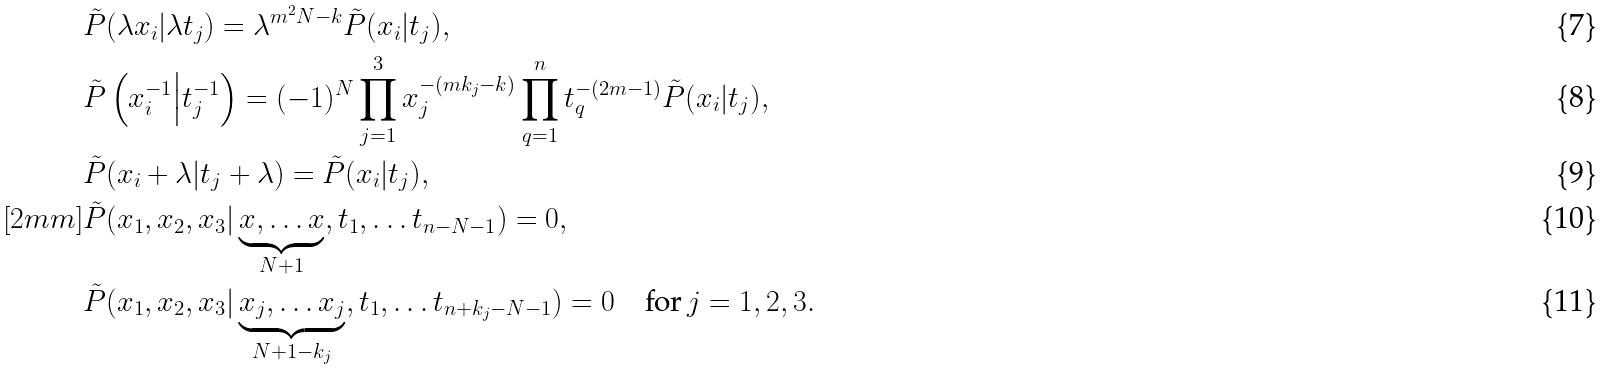Convert formula to latex. <formula><loc_0><loc_0><loc_500><loc_500>& \tilde { P } ( \lambda x _ { i } | \lambda t _ { j } ) = \lambda ^ { m ^ { 2 } N - k } \tilde { P } ( x _ { i } | t _ { j } ) , \\ & \tilde { P } \left ( x _ { i } ^ { - 1 } \Big | t _ { j } ^ { - 1 } \right ) = ( - 1 ) ^ { N } \prod _ { j = 1 } ^ { 3 } x _ { j } ^ { - ( m k _ { j } - k ) } \prod _ { q = 1 } ^ { n } t _ { q } ^ { - ( 2 m - 1 ) } \tilde { P } ( x _ { i } | t _ { j } ) , \\ & \tilde { P } ( x _ { i } + \lambda | t _ { j } + \lambda ) = \tilde { P } ( x _ { i } | t _ { j } ) , \\ [ 2 m m ] & \tilde { P } ( x _ { 1 } , x _ { 2 } , x _ { 3 } | \underbrace { x , \dots x } _ { N + 1 } , t _ { 1 } , \dots t _ { n - N - 1 } ) = 0 , \\ & \tilde { P } ( x _ { 1 } , x _ { 2 } , x _ { 3 } | \underbrace { x _ { j } , \dots x _ { j } } _ { N + 1 - k _ { j } } , t _ { 1 } , \dots t _ { n + k _ { j } - N - 1 } ) = 0 \quad \text {for} \, j = 1 , 2 , 3 .</formula> 